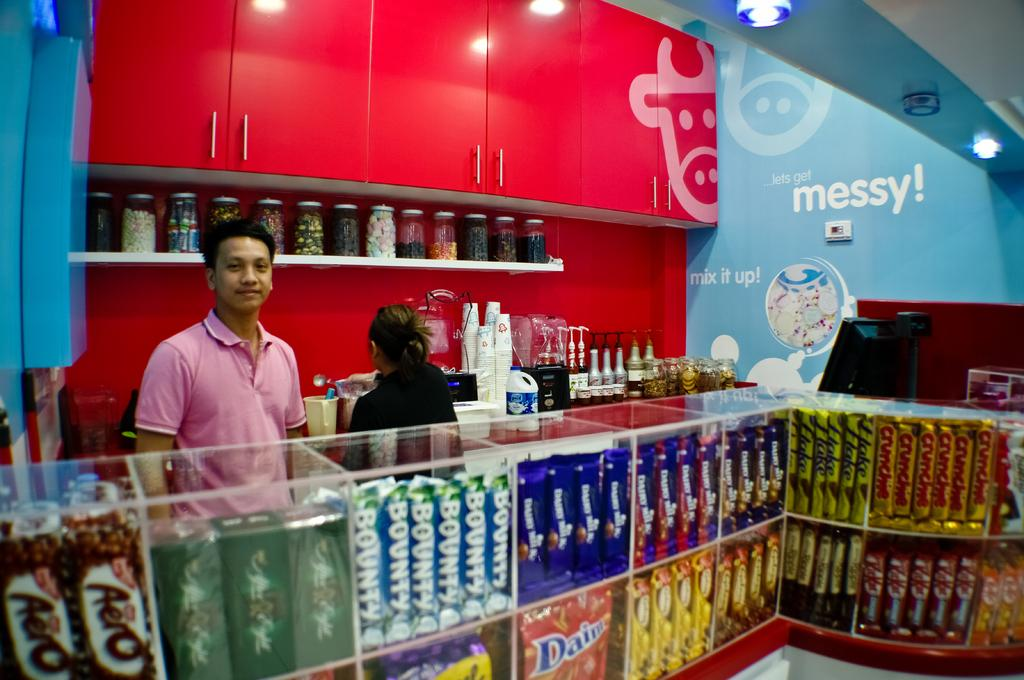Provide a one-sentence caption for the provided image. A store's walls carry messages like Mix It Up! and Messy!. 